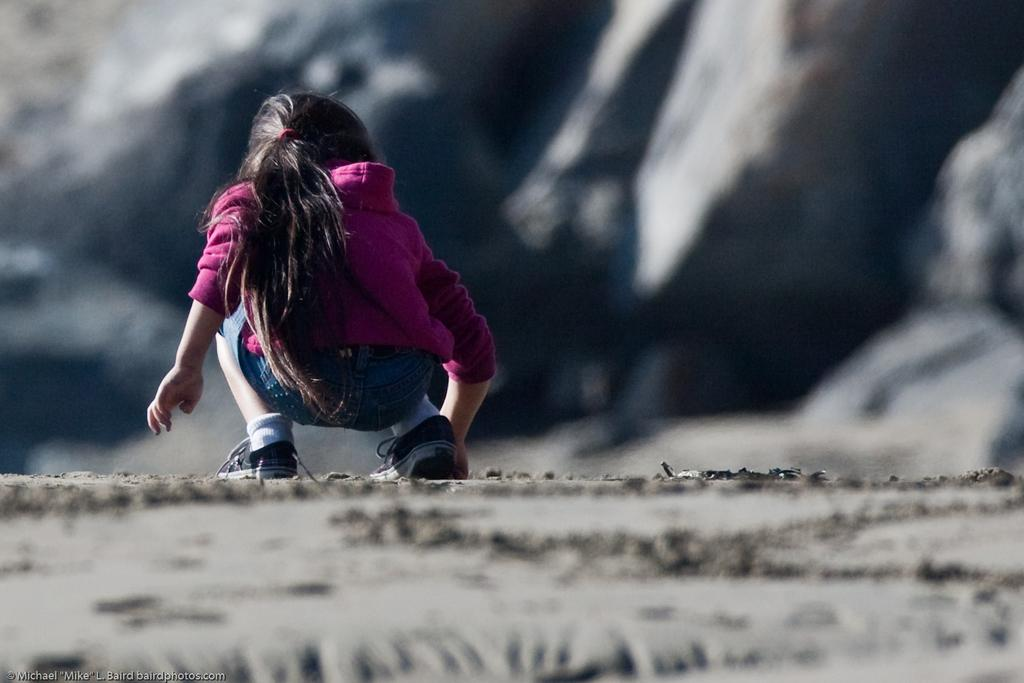Who is the main subject in the image? There is a girl in the image. What is the girl wearing? The girl is wearing a dress. Where is the girl standing? The girl is standing on the ground. What can be seen at the bottom of the image? There is text visible at the bottom of the image. What type of whip is being used by the girl in the image? There is no whip present in the image; the girl is simply standing on the ground. What kind of feast is being prepared in the image? There is no feast or any indication of food preparation in the image. 